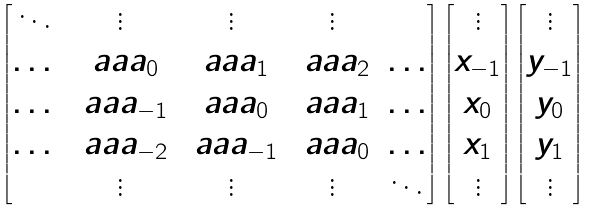<formula> <loc_0><loc_0><loc_500><loc_500>\begin{bmatrix} \ddots & \vdots & \vdots & \vdots & \\ \dots & \ a a a _ { 0 } & \ a a a _ { 1 } & \ a a a _ { 2 } & \dots \\ \dots & \ a a a _ { - 1 } & \ a a a _ { 0 } & \ a a a _ { 1 } & \dots \\ \dots & \ a a a _ { - 2 } & \ a a a _ { - 1 } & \ a a a _ { 0 } & \dots \\ & \vdots & \vdots & \vdots & \ddots \\ \end{bmatrix} \, \begin{bmatrix} \vdots \\ x _ { - 1 } \\ x _ { 0 } \\ x _ { 1 } \\ \vdots \end{bmatrix} \begin{bmatrix} \vdots \\ y _ { - 1 } \\ y _ { 0 } \\ y _ { 1 } \\ \vdots \end{bmatrix}</formula> 